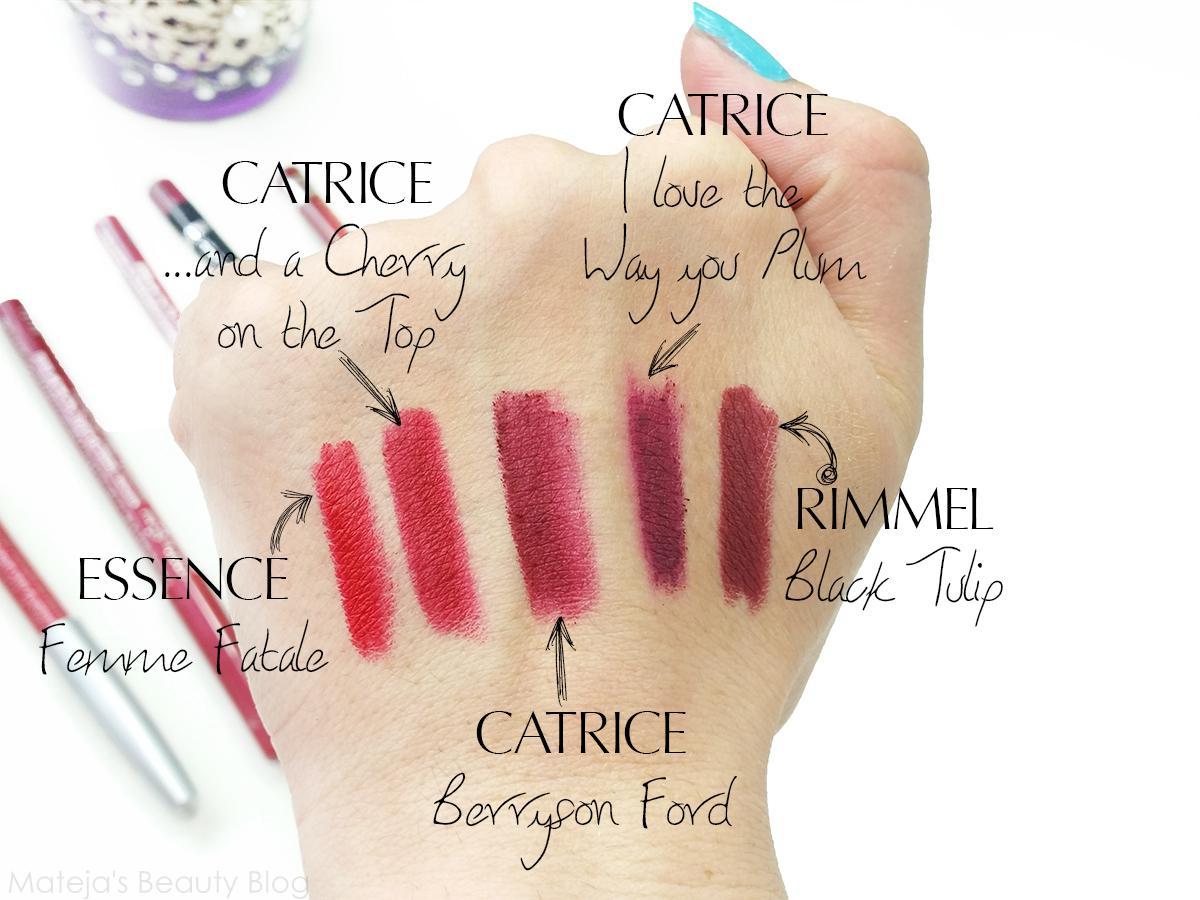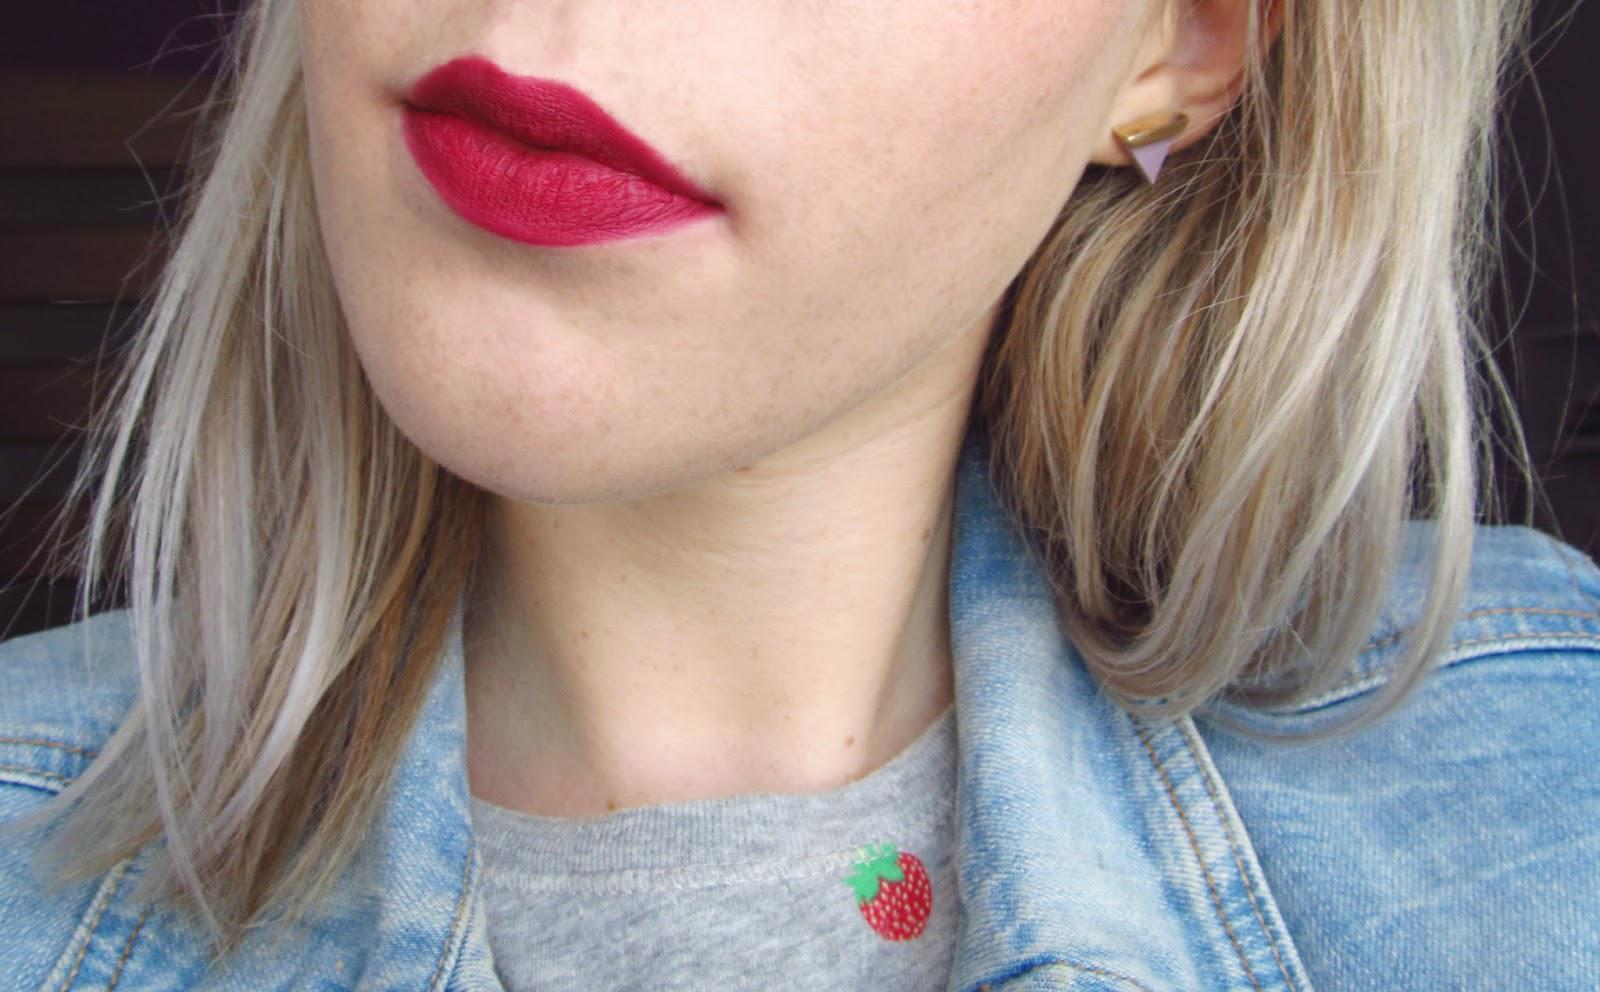The first image is the image on the left, the second image is the image on the right. Assess this claim about the two images: "There is a woman wearing lipstick on the right image and swatches of lip products on the left.". Correct or not? Answer yes or no. Yes. The first image is the image on the left, the second image is the image on the right. Evaluate the accuracy of this statement regarding the images: "One image includes multiple deep-red painted fingernails, and at least one image includes tinted lips.". Is it true? Answer yes or no. No. 